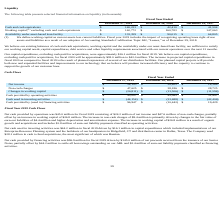From Chefs Wharehouse's financial document, What is the Cash and cash equivalents for fiscal years 2019, 2018 and 2017 respectively? The document contains multiple relevant values: $140,233, $42,410, $41,504 (in thousands). From the document: "Cash and cash equivalents $ 140,233 $ 42,410 $ 41,504 Cash and cash equivalents $ 140,233 $ 42,410 $ 41,504 Cash and cash equivalents $ 140,233 $ 42,4..." Also, What is the Working capital, excluding cash and cash equivalents for fiscal years 2019, 2018 and 2017 respectively? The document contains multiple relevant values: $162,772, $160,783, $147,063 (in thousands). From the document: "g cash and cash equivalents $ 162,772 $ 160,783 $ 147,063 ) excluding cash and cash equivalents $ 162,772 $ 160,783 $ 147,063 apital, (1) excluding ca..." Also, What is the Availability under asset-based loan facility for fiscal years 2019, 2018 and 2017 respectively? The document contains multiple relevant values: $133,359, $90,015, $64,805 (in thousands). From the document: "Availability under asset-based loan facility $ 133,359 $ 90,015 $ 64,805 er asset-based loan facility $ 133,359 $ 90,015 $ 64,805 ility under asset-ba..." Also, can you calculate: What is the average value for the Cash and cash equivalents for fiscal years 2019, 2018 and 2017? To answer this question, I need to perform calculations using the financial data. The calculation is: (140,233+ 42,410+ 41,504)/3, which equals 74715.67 (in thousands). This is based on the information: "Cash and cash equivalents $ 140,233 $ 42,410 $ 41,504 Cash and cash equivalents $ 140,233 $ 42,410 $ 41,504 Cash and cash equivalents $ 140,233 $ 42,410 $ 41,504..." The key data points involved are: 140,233, 41,504, 42,410. Also, can you calculate: What is the average value for the Availability under asset-based loan facility for fiscal years 2019, 2018 and 2017? To answer this question, I need to perform calculations using the financial data. The calculation is: (133,359+ 90,015+ 64,805)/3, which equals 96059.67 (in thousands). This is based on the information: "er asset-based loan facility $ 133,359 $ 90,015 $ 64,805 Availability under asset-based loan facility $ 133,359 $ 90,015 $ 64,805 ility under asset-based loan facility $ 133,359 $ 90,015 $ 64,805..." The key data points involved are: 133,359, 64,805, 90,015. Additionally, Which year has the highest Cash and cash equivalents? According to the financial document, 2019. The relevant text states: "December 27, 2019 December 28, 2018 December 29, 2017..." 